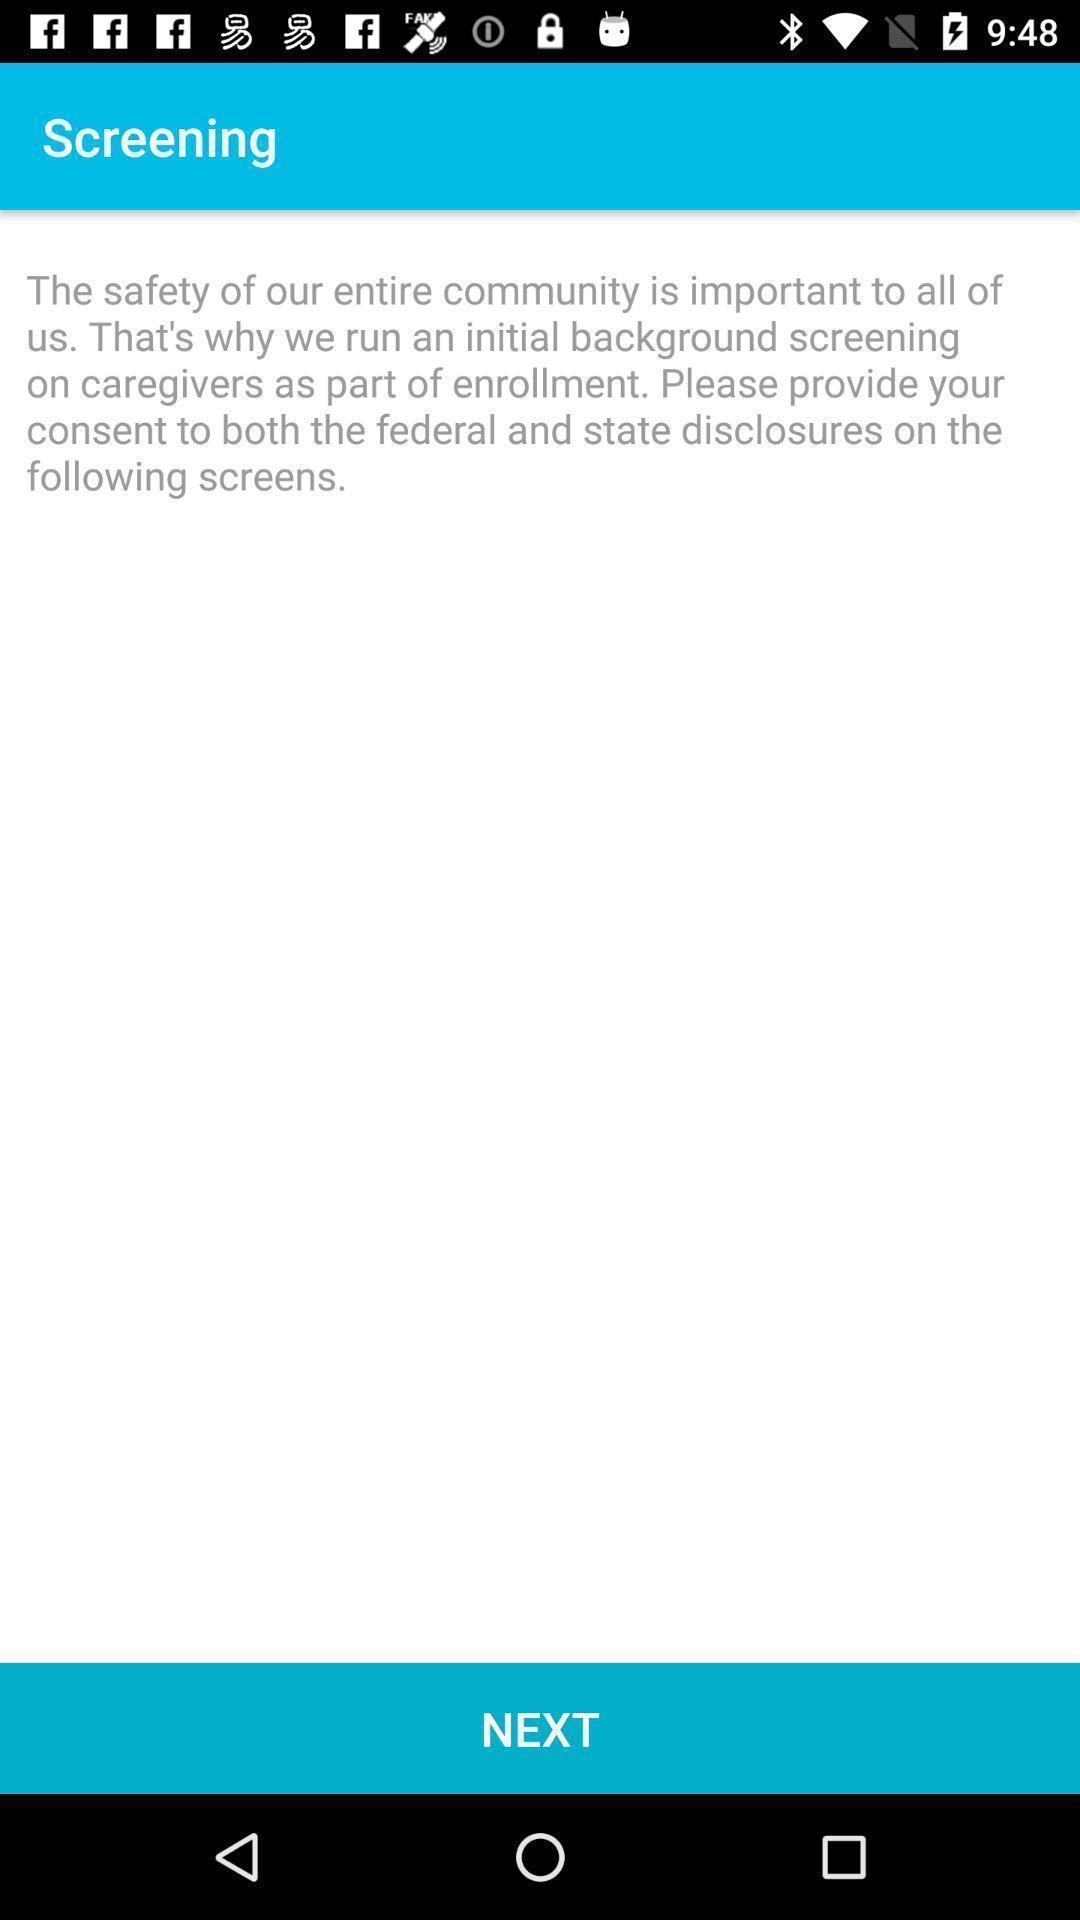Please provide a description for this image. Page of screening for the app. 